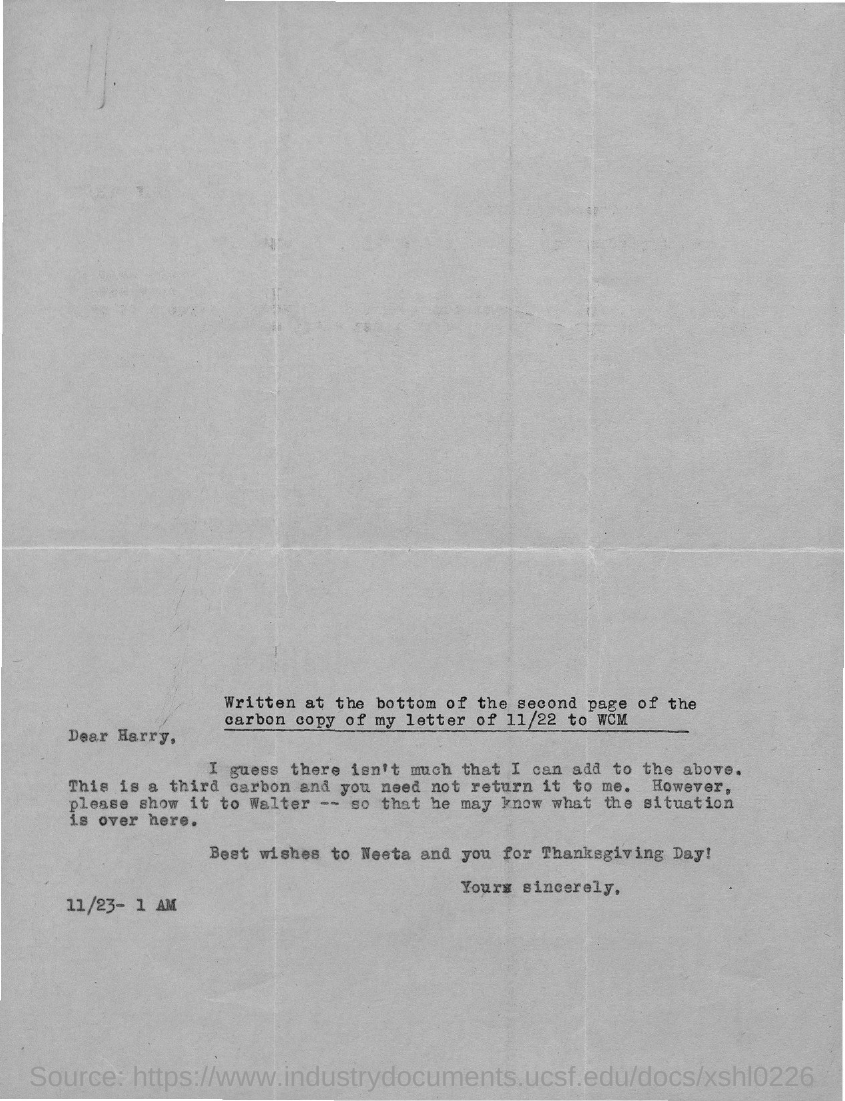List a handful of essential elements in this visual. The letter is addressed to Harry. 